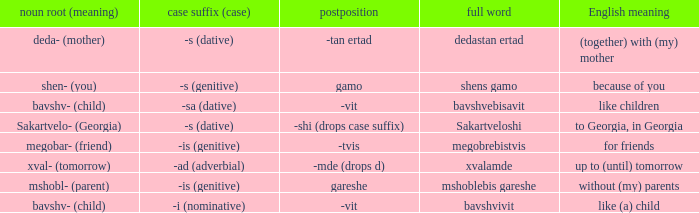What is Postposition, when Noun Root (Meaning) is "mshobl- (parent)"? Gareshe. 